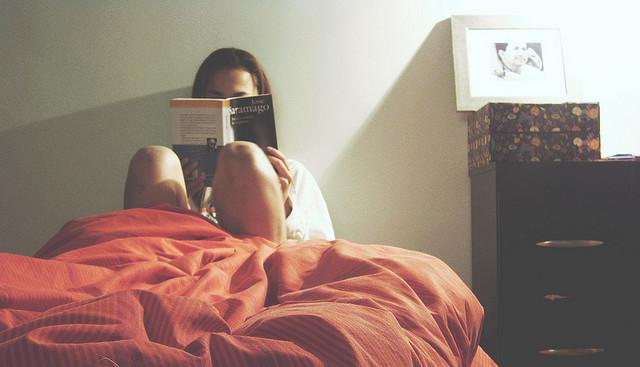What is the woman featured in this picture reading?
Quick response, please. Book. How many framed pictures can be seen?
Short answer required. 1. How many people are shown this picture?
Concise answer only. 1. 